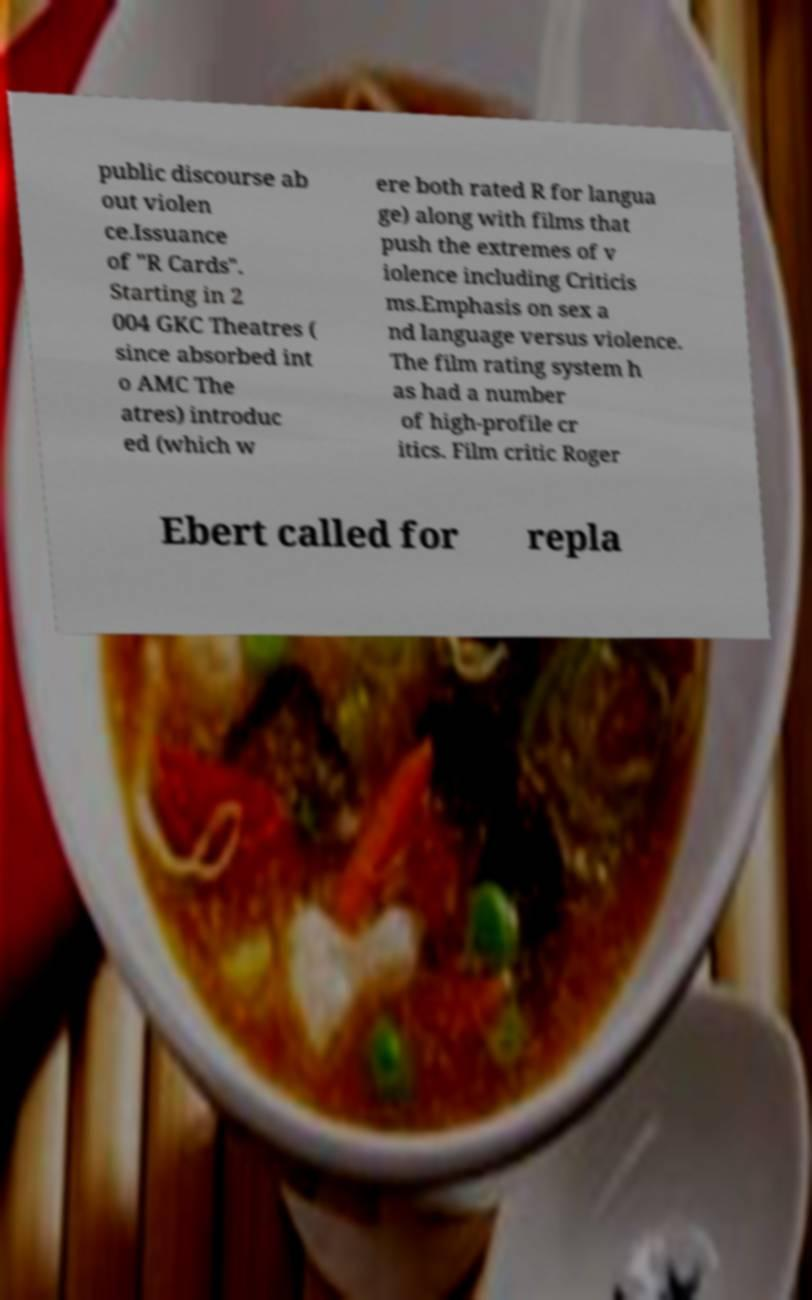Can you read and provide the text displayed in the image?This photo seems to have some interesting text. Can you extract and type it out for me? public discourse ab out violen ce.Issuance of "R Cards". Starting in 2 004 GKC Theatres ( since absorbed int o AMC The atres) introduc ed (which w ere both rated R for langua ge) along with films that push the extremes of v iolence including Criticis ms.Emphasis on sex a nd language versus violence. The film rating system h as had a number of high-profile cr itics. Film critic Roger Ebert called for repla 